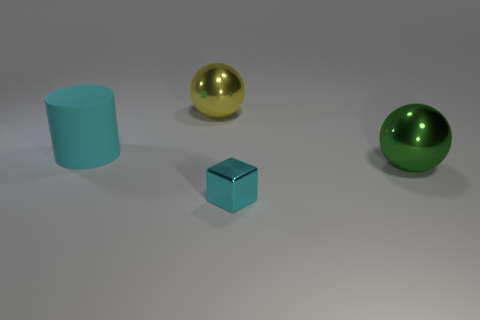There is a yellow metal object that is the same shape as the green metallic thing; what size is it?
Offer a very short reply. Large. Are there any other things that are made of the same material as the large cylinder?
Offer a terse response. No. There is a metallic sphere in front of the yellow metallic thing; is it the same size as the ball behind the big matte cylinder?
Your response must be concise. Yes. How many tiny things are either gray rubber things or cyan matte cylinders?
Offer a terse response. 0. What number of large things are both to the left of the yellow metal sphere and in front of the cyan rubber cylinder?
Make the answer very short. 0. Is the green thing made of the same material as the cyan thing behind the small cyan cube?
Offer a terse response. No. How many gray things are metallic cubes or balls?
Ensure brevity in your answer.  0. Are there any green matte things of the same size as the metal block?
Give a very brief answer. No. There is a big ball that is in front of the big metallic ball that is left of the big shiny ball to the right of the large yellow shiny sphere; what is it made of?
Your response must be concise. Metal. Is the number of metal objects that are behind the large yellow sphere the same as the number of large cyan metal spheres?
Your answer should be very brief. Yes. 